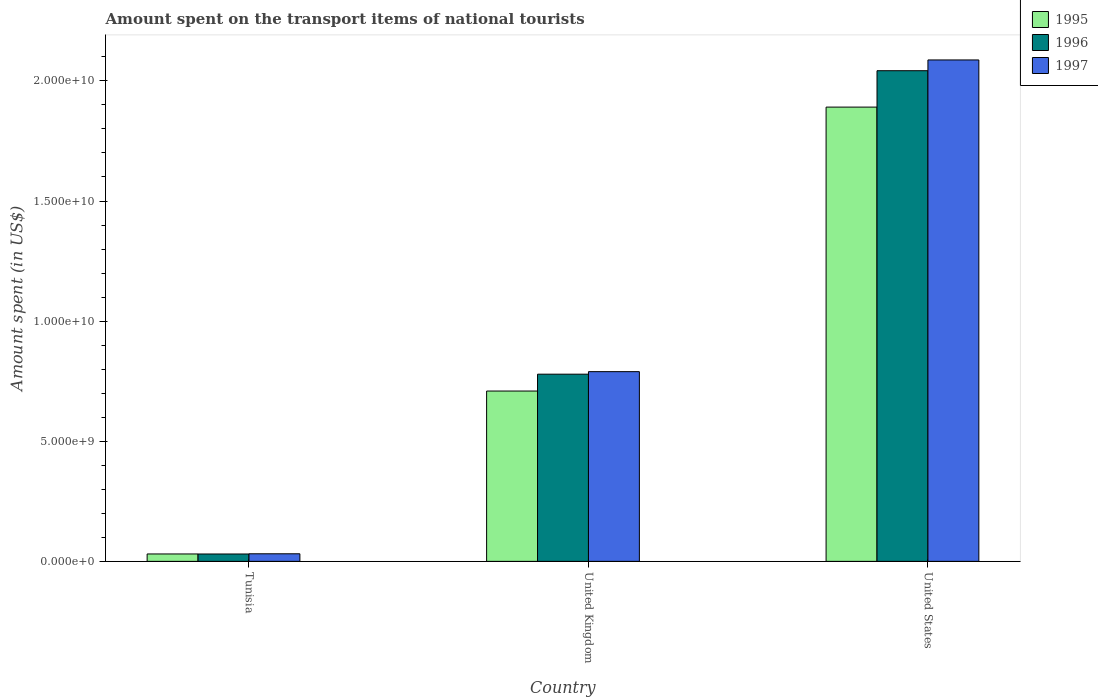How many bars are there on the 2nd tick from the left?
Your answer should be very brief. 3. What is the label of the 1st group of bars from the left?
Your answer should be compact. Tunisia. What is the amount spent on the transport items of national tourists in 1995 in United States?
Provide a succinct answer. 1.89e+1. Across all countries, what is the maximum amount spent on the transport items of national tourists in 1997?
Provide a succinct answer. 2.09e+1. Across all countries, what is the minimum amount spent on the transport items of national tourists in 1997?
Make the answer very short. 3.15e+08. In which country was the amount spent on the transport items of national tourists in 1995 minimum?
Ensure brevity in your answer.  Tunisia. What is the total amount spent on the transport items of national tourists in 1995 in the graph?
Provide a short and direct response. 2.63e+1. What is the difference between the amount spent on the transport items of national tourists in 1995 in Tunisia and that in United Kingdom?
Make the answer very short. -6.78e+09. What is the difference between the amount spent on the transport items of national tourists in 1995 in United Kingdom and the amount spent on the transport items of national tourists in 1997 in United States?
Offer a terse response. -1.38e+1. What is the average amount spent on the transport items of national tourists in 1995 per country?
Make the answer very short. 8.77e+09. What is the difference between the amount spent on the transport items of national tourists of/in 1997 and amount spent on the transport items of national tourists of/in 1995 in United States?
Give a very brief answer. 1.96e+09. What is the ratio of the amount spent on the transport items of national tourists in 1996 in United Kingdom to that in United States?
Provide a short and direct response. 0.38. Is the amount spent on the transport items of national tourists in 1995 in Tunisia less than that in United Kingdom?
Keep it short and to the point. Yes. Is the difference between the amount spent on the transport items of national tourists in 1997 in Tunisia and United States greater than the difference between the amount spent on the transport items of national tourists in 1995 in Tunisia and United States?
Your response must be concise. No. What is the difference between the highest and the second highest amount spent on the transport items of national tourists in 1995?
Your answer should be very brief. 1.86e+1. What is the difference between the highest and the lowest amount spent on the transport items of national tourists in 1995?
Offer a very short reply. 1.86e+1. In how many countries, is the amount spent on the transport items of national tourists in 1996 greater than the average amount spent on the transport items of national tourists in 1996 taken over all countries?
Your response must be concise. 1. How many bars are there?
Provide a succinct answer. 9. What is the difference between two consecutive major ticks on the Y-axis?
Offer a very short reply. 5.00e+09. Are the values on the major ticks of Y-axis written in scientific E-notation?
Provide a succinct answer. Yes. Does the graph contain grids?
Your answer should be very brief. No. What is the title of the graph?
Ensure brevity in your answer.  Amount spent on the transport items of national tourists. What is the label or title of the X-axis?
Keep it short and to the point. Country. What is the label or title of the Y-axis?
Your answer should be very brief. Amount spent (in US$). What is the Amount spent (in US$) of 1995 in Tunisia?
Keep it short and to the point. 3.08e+08. What is the Amount spent (in US$) of 1996 in Tunisia?
Offer a very short reply. 3.07e+08. What is the Amount spent (in US$) of 1997 in Tunisia?
Ensure brevity in your answer.  3.15e+08. What is the Amount spent (in US$) of 1995 in United Kingdom?
Give a very brief answer. 7.09e+09. What is the Amount spent (in US$) of 1996 in United Kingdom?
Offer a very short reply. 7.79e+09. What is the Amount spent (in US$) in 1997 in United Kingdom?
Give a very brief answer. 7.90e+09. What is the Amount spent (in US$) of 1995 in United States?
Your response must be concise. 1.89e+1. What is the Amount spent (in US$) of 1996 in United States?
Keep it short and to the point. 2.04e+1. What is the Amount spent (in US$) of 1997 in United States?
Offer a very short reply. 2.09e+1. Across all countries, what is the maximum Amount spent (in US$) in 1995?
Offer a very short reply. 1.89e+1. Across all countries, what is the maximum Amount spent (in US$) in 1996?
Your answer should be very brief. 2.04e+1. Across all countries, what is the maximum Amount spent (in US$) in 1997?
Offer a very short reply. 2.09e+1. Across all countries, what is the minimum Amount spent (in US$) in 1995?
Keep it short and to the point. 3.08e+08. Across all countries, what is the minimum Amount spent (in US$) in 1996?
Ensure brevity in your answer.  3.07e+08. Across all countries, what is the minimum Amount spent (in US$) in 1997?
Your response must be concise. 3.15e+08. What is the total Amount spent (in US$) in 1995 in the graph?
Your answer should be very brief. 2.63e+1. What is the total Amount spent (in US$) of 1996 in the graph?
Your response must be concise. 2.85e+1. What is the total Amount spent (in US$) of 1997 in the graph?
Give a very brief answer. 2.91e+1. What is the difference between the Amount spent (in US$) of 1995 in Tunisia and that in United Kingdom?
Your answer should be compact. -6.78e+09. What is the difference between the Amount spent (in US$) in 1996 in Tunisia and that in United Kingdom?
Give a very brief answer. -7.48e+09. What is the difference between the Amount spent (in US$) of 1997 in Tunisia and that in United Kingdom?
Offer a very short reply. -7.58e+09. What is the difference between the Amount spent (in US$) in 1995 in Tunisia and that in United States?
Provide a short and direct response. -1.86e+1. What is the difference between the Amount spent (in US$) of 1996 in Tunisia and that in United States?
Give a very brief answer. -2.01e+1. What is the difference between the Amount spent (in US$) in 1997 in Tunisia and that in United States?
Offer a terse response. -2.06e+1. What is the difference between the Amount spent (in US$) of 1995 in United Kingdom and that in United States?
Keep it short and to the point. -1.18e+1. What is the difference between the Amount spent (in US$) in 1996 in United Kingdom and that in United States?
Your response must be concise. -1.26e+1. What is the difference between the Amount spent (in US$) in 1997 in United Kingdom and that in United States?
Ensure brevity in your answer.  -1.30e+1. What is the difference between the Amount spent (in US$) in 1995 in Tunisia and the Amount spent (in US$) in 1996 in United Kingdom?
Give a very brief answer. -7.48e+09. What is the difference between the Amount spent (in US$) of 1995 in Tunisia and the Amount spent (in US$) of 1997 in United Kingdom?
Your response must be concise. -7.59e+09. What is the difference between the Amount spent (in US$) in 1996 in Tunisia and the Amount spent (in US$) in 1997 in United Kingdom?
Offer a very short reply. -7.59e+09. What is the difference between the Amount spent (in US$) of 1995 in Tunisia and the Amount spent (in US$) of 1996 in United States?
Give a very brief answer. -2.01e+1. What is the difference between the Amount spent (in US$) in 1995 in Tunisia and the Amount spent (in US$) in 1997 in United States?
Provide a short and direct response. -2.06e+1. What is the difference between the Amount spent (in US$) in 1996 in Tunisia and the Amount spent (in US$) in 1997 in United States?
Your answer should be very brief. -2.06e+1. What is the difference between the Amount spent (in US$) of 1995 in United Kingdom and the Amount spent (in US$) of 1996 in United States?
Your answer should be compact. -1.33e+1. What is the difference between the Amount spent (in US$) in 1995 in United Kingdom and the Amount spent (in US$) in 1997 in United States?
Ensure brevity in your answer.  -1.38e+1. What is the difference between the Amount spent (in US$) in 1996 in United Kingdom and the Amount spent (in US$) in 1997 in United States?
Offer a very short reply. -1.31e+1. What is the average Amount spent (in US$) in 1995 per country?
Offer a terse response. 8.77e+09. What is the average Amount spent (in US$) in 1996 per country?
Ensure brevity in your answer.  9.51e+09. What is the average Amount spent (in US$) in 1997 per country?
Your response must be concise. 9.69e+09. What is the difference between the Amount spent (in US$) in 1995 and Amount spent (in US$) in 1996 in Tunisia?
Your answer should be very brief. 1.00e+06. What is the difference between the Amount spent (in US$) in 1995 and Amount spent (in US$) in 1997 in Tunisia?
Your answer should be compact. -7.00e+06. What is the difference between the Amount spent (in US$) of 1996 and Amount spent (in US$) of 1997 in Tunisia?
Give a very brief answer. -8.00e+06. What is the difference between the Amount spent (in US$) of 1995 and Amount spent (in US$) of 1996 in United Kingdom?
Your response must be concise. -7.02e+08. What is the difference between the Amount spent (in US$) of 1995 and Amount spent (in US$) of 1997 in United Kingdom?
Offer a very short reply. -8.07e+08. What is the difference between the Amount spent (in US$) in 1996 and Amount spent (in US$) in 1997 in United Kingdom?
Your answer should be very brief. -1.05e+08. What is the difference between the Amount spent (in US$) of 1995 and Amount spent (in US$) of 1996 in United States?
Provide a succinct answer. -1.52e+09. What is the difference between the Amount spent (in US$) of 1995 and Amount spent (in US$) of 1997 in United States?
Keep it short and to the point. -1.96e+09. What is the difference between the Amount spent (in US$) in 1996 and Amount spent (in US$) in 1997 in United States?
Offer a very short reply. -4.48e+08. What is the ratio of the Amount spent (in US$) in 1995 in Tunisia to that in United Kingdom?
Provide a short and direct response. 0.04. What is the ratio of the Amount spent (in US$) in 1996 in Tunisia to that in United Kingdom?
Provide a short and direct response. 0.04. What is the ratio of the Amount spent (in US$) in 1997 in Tunisia to that in United Kingdom?
Your answer should be compact. 0.04. What is the ratio of the Amount spent (in US$) in 1995 in Tunisia to that in United States?
Offer a very short reply. 0.02. What is the ratio of the Amount spent (in US$) of 1996 in Tunisia to that in United States?
Keep it short and to the point. 0.01. What is the ratio of the Amount spent (in US$) in 1997 in Tunisia to that in United States?
Keep it short and to the point. 0.02. What is the ratio of the Amount spent (in US$) of 1996 in United Kingdom to that in United States?
Your answer should be compact. 0.38. What is the ratio of the Amount spent (in US$) in 1997 in United Kingdom to that in United States?
Offer a very short reply. 0.38. What is the difference between the highest and the second highest Amount spent (in US$) of 1995?
Make the answer very short. 1.18e+1. What is the difference between the highest and the second highest Amount spent (in US$) in 1996?
Your answer should be very brief. 1.26e+1. What is the difference between the highest and the second highest Amount spent (in US$) in 1997?
Provide a short and direct response. 1.30e+1. What is the difference between the highest and the lowest Amount spent (in US$) of 1995?
Ensure brevity in your answer.  1.86e+1. What is the difference between the highest and the lowest Amount spent (in US$) of 1996?
Keep it short and to the point. 2.01e+1. What is the difference between the highest and the lowest Amount spent (in US$) of 1997?
Ensure brevity in your answer.  2.06e+1. 